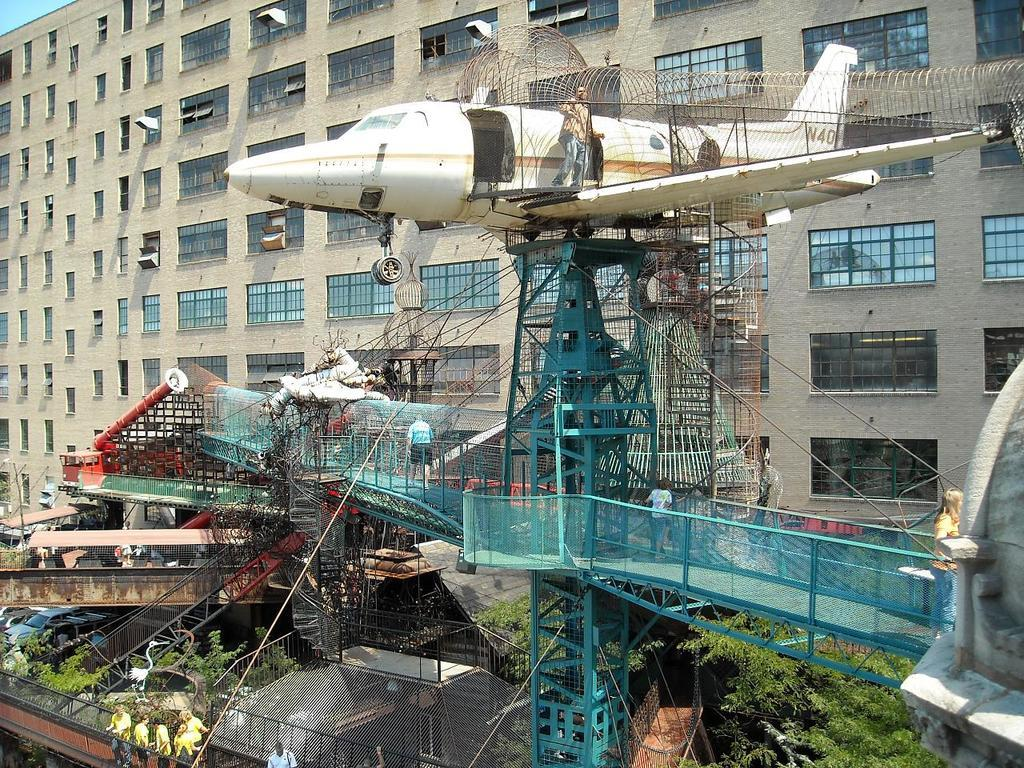What is the main subject of the image? The main subject of the image is an airplane. Where is the airplane located in the image? The airplane is standing on a bridge. What can be seen in the front of the image? There are trees in the front of the image. Are there any people visible in the image? Yes, there are persons standing in the image. What is visible in the background of the image? There is a building in the background of the image. What is the love rate of the doctor in the image? There is no doctor or mention of love in the image, so it is not possible to determine a love rate. 